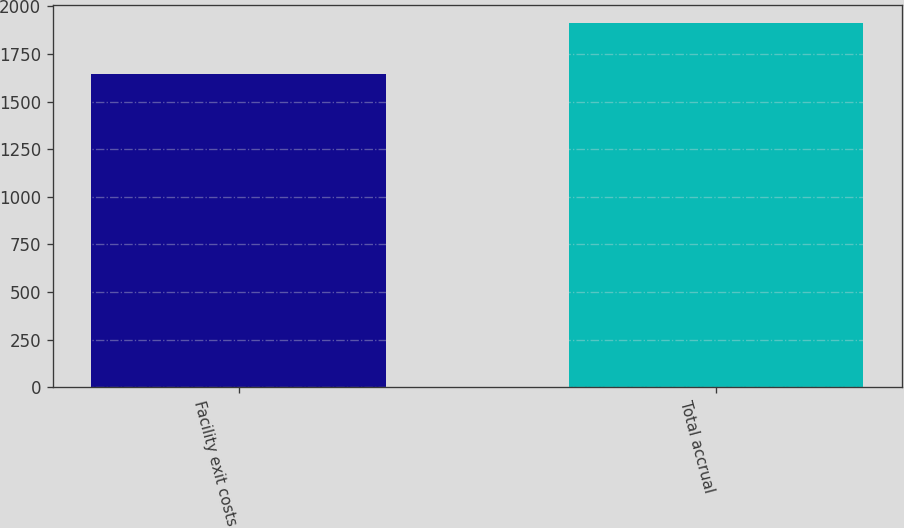<chart> <loc_0><loc_0><loc_500><loc_500><bar_chart><fcel>Facility exit costs<fcel>Total accrual<nl><fcel>1642<fcel>1910<nl></chart> 